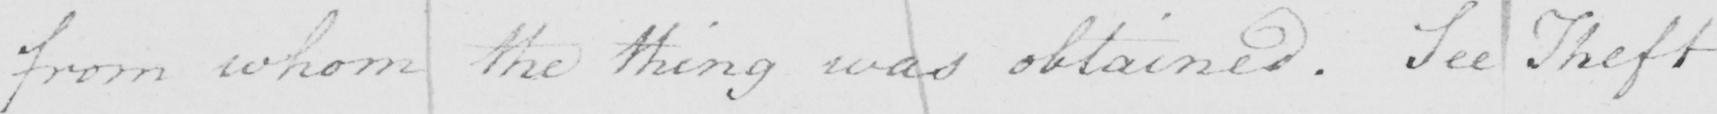What text is written in this handwritten line? from whom the thing was obtained . See Theft 